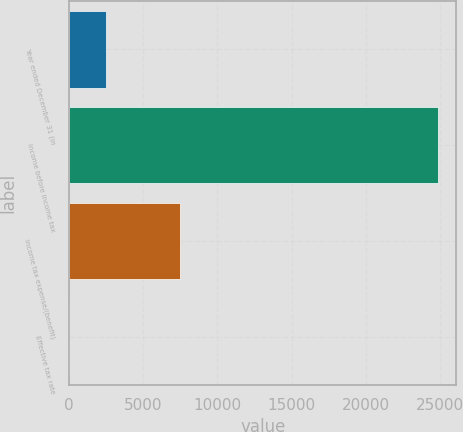Convert chart. <chart><loc_0><loc_0><loc_500><loc_500><bar_chart><fcel>Year ended December 31 (in<fcel>Income before income tax<fcel>Income tax expense/(benefit)<fcel>Effective tax rate<nl><fcel>2512.99<fcel>24859<fcel>7489<fcel>30.1<nl></chart> 